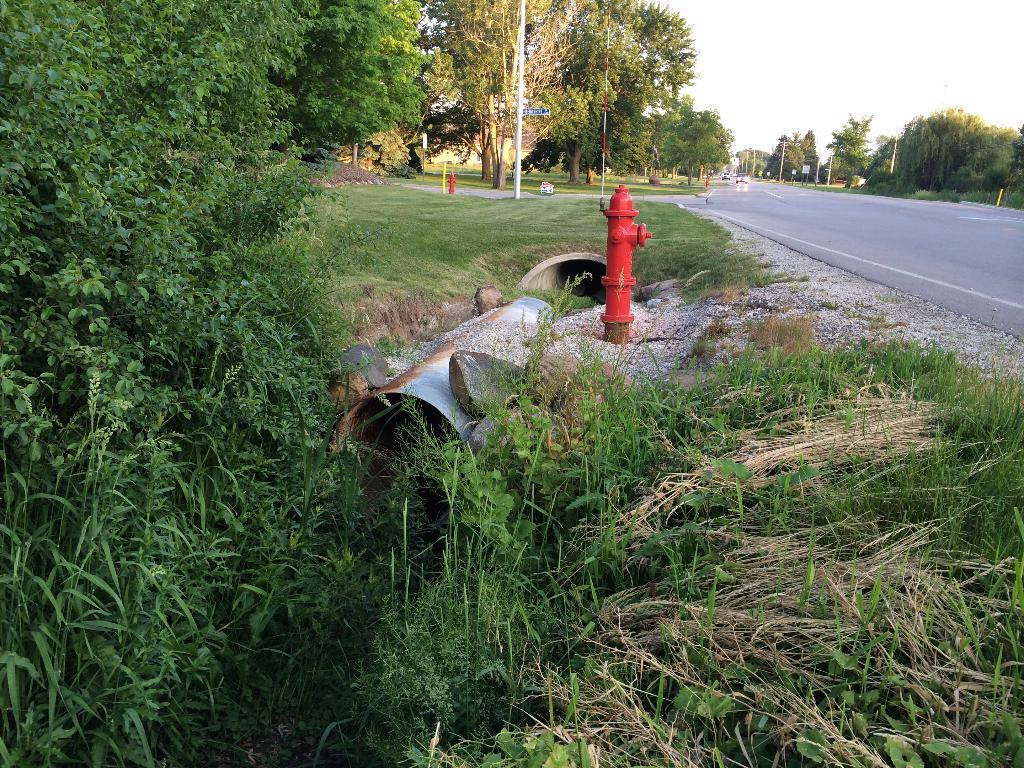What is located on the right side of the image? There is a road on the right side of the image. What type of vegetation is at the bottom of the image? There is grass at the bottom of the image. What objects can be seen in the image that are used for transporting fluids? There are pipes in the image. What can be seen in the background of the image? There are trees, poles, and the sky visible in the background of the image. What objects in the image are used for firefighting? There are hydrants in the image. What type of ball is being used by the authority figure in the image? There is no authority figure or ball present in the image. What is the purpose of the pipes in the image? The purpose of the pipes in the image cannot be determined from the image alone, as it does not provide information about their function or use. 